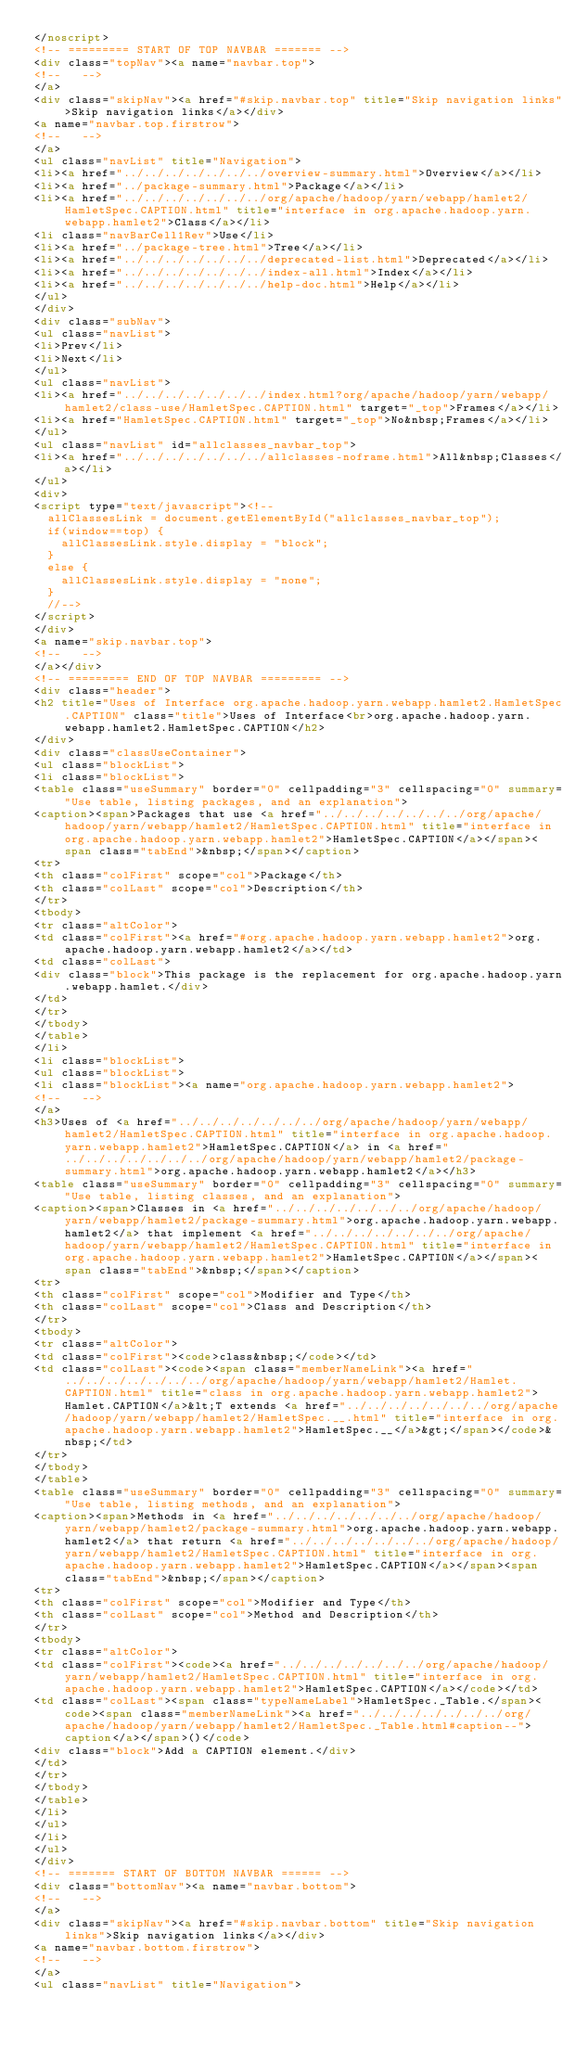<code> <loc_0><loc_0><loc_500><loc_500><_HTML_></noscript>
<!-- ========= START OF TOP NAVBAR ======= -->
<div class="topNav"><a name="navbar.top">
<!--   -->
</a>
<div class="skipNav"><a href="#skip.navbar.top" title="Skip navigation links">Skip navigation links</a></div>
<a name="navbar.top.firstrow">
<!--   -->
</a>
<ul class="navList" title="Navigation">
<li><a href="../../../../../../../overview-summary.html">Overview</a></li>
<li><a href="../package-summary.html">Package</a></li>
<li><a href="../../../../../../../org/apache/hadoop/yarn/webapp/hamlet2/HamletSpec.CAPTION.html" title="interface in org.apache.hadoop.yarn.webapp.hamlet2">Class</a></li>
<li class="navBarCell1Rev">Use</li>
<li><a href="../package-tree.html">Tree</a></li>
<li><a href="../../../../../../../deprecated-list.html">Deprecated</a></li>
<li><a href="../../../../../../../index-all.html">Index</a></li>
<li><a href="../../../../../../../help-doc.html">Help</a></li>
</ul>
</div>
<div class="subNav">
<ul class="navList">
<li>Prev</li>
<li>Next</li>
</ul>
<ul class="navList">
<li><a href="../../../../../../../index.html?org/apache/hadoop/yarn/webapp/hamlet2/class-use/HamletSpec.CAPTION.html" target="_top">Frames</a></li>
<li><a href="HamletSpec.CAPTION.html" target="_top">No&nbsp;Frames</a></li>
</ul>
<ul class="navList" id="allclasses_navbar_top">
<li><a href="../../../../../../../allclasses-noframe.html">All&nbsp;Classes</a></li>
</ul>
<div>
<script type="text/javascript"><!--
  allClassesLink = document.getElementById("allclasses_navbar_top");
  if(window==top) {
    allClassesLink.style.display = "block";
  }
  else {
    allClassesLink.style.display = "none";
  }
  //-->
</script>
</div>
<a name="skip.navbar.top">
<!--   -->
</a></div>
<!-- ========= END OF TOP NAVBAR ========= -->
<div class="header">
<h2 title="Uses of Interface org.apache.hadoop.yarn.webapp.hamlet2.HamletSpec.CAPTION" class="title">Uses of Interface<br>org.apache.hadoop.yarn.webapp.hamlet2.HamletSpec.CAPTION</h2>
</div>
<div class="classUseContainer">
<ul class="blockList">
<li class="blockList">
<table class="useSummary" border="0" cellpadding="3" cellspacing="0" summary="Use table, listing packages, and an explanation">
<caption><span>Packages that use <a href="../../../../../../../org/apache/hadoop/yarn/webapp/hamlet2/HamletSpec.CAPTION.html" title="interface in org.apache.hadoop.yarn.webapp.hamlet2">HamletSpec.CAPTION</a></span><span class="tabEnd">&nbsp;</span></caption>
<tr>
<th class="colFirst" scope="col">Package</th>
<th class="colLast" scope="col">Description</th>
</tr>
<tbody>
<tr class="altColor">
<td class="colFirst"><a href="#org.apache.hadoop.yarn.webapp.hamlet2">org.apache.hadoop.yarn.webapp.hamlet2</a></td>
<td class="colLast">
<div class="block">This package is the replacement for org.apache.hadoop.yarn.webapp.hamlet.</div>
</td>
</tr>
</tbody>
</table>
</li>
<li class="blockList">
<ul class="blockList">
<li class="blockList"><a name="org.apache.hadoop.yarn.webapp.hamlet2">
<!--   -->
</a>
<h3>Uses of <a href="../../../../../../../org/apache/hadoop/yarn/webapp/hamlet2/HamletSpec.CAPTION.html" title="interface in org.apache.hadoop.yarn.webapp.hamlet2">HamletSpec.CAPTION</a> in <a href="../../../../../../../org/apache/hadoop/yarn/webapp/hamlet2/package-summary.html">org.apache.hadoop.yarn.webapp.hamlet2</a></h3>
<table class="useSummary" border="0" cellpadding="3" cellspacing="0" summary="Use table, listing classes, and an explanation">
<caption><span>Classes in <a href="../../../../../../../org/apache/hadoop/yarn/webapp/hamlet2/package-summary.html">org.apache.hadoop.yarn.webapp.hamlet2</a> that implement <a href="../../../../../../../org/apache/hadoop/yarn/webapp/hamlet2/HamletSpec.CAPTION.html" title="interface in org.apache.hadoop.yarn.webapp.hamlet2">HamletSpec.CAPTION</a></span><span class="tabEnd">&nbsp;</span></caption>
<tr>
<th class="colFirst" scope="col">Modifier and Type</th>
<th class="colLast" scope="col">Class and Description</th>
</tr>
<tbody>
<tr class="altColor">
<td class="colFirst"><code>class&nbsp;</code></td>
<td class="colLast"><code><span class="memberNameLink"><a href="../../../../../../../org/apache/hadoop/yarn/webapp/hamlet2/Hamlet.CAPTION.html" title="class in org.apache.hadoop.yarn.webapp.hamlet2">Hamlet.CAPTION</a>&lt;T extends <a href="../../../../../../../org/apache/hadoop/yarn/webapp/hamlet2/HamletSpec.__.html" title="interface in org.apache.hadoop.yarn.webapp.hamlet2">HamletSpec.__</a>&gt;</span></code>&nbsp;</td>
</tr>
</tbody>
</table>
<table class="useSummary" border="0" cellpadding="3" cellspacing="0" summary="Use table, listing methods, and an explanation">
<caption><span>Methods in <a href="../../../../../../../org/apache/hadoop/yarn/webapp/hamlet2/package-summary.html">org.apache.hadoop.yarn.webapp.hamlet2</a> that return <a href="../../../../../../../org/apache/hadoop/yarn/webapp/hamlet2/HamletSpec.CAPTION.html" title="interface in org.apache.hadoop.yarn.webapp.hamlet2">HamletSpec.CAPTION</a></span><span class="tabEnd">&nbsp;</span></caption>
<tr>
<th class="colFirst" scope="col">Modifier and Type</th>
<th class="colLast" scope="col">Method and Description</th>
</tr>
<tbody>
<tr class="altColor">
<td class="colFirst"><code><a href="../../../../../../../org/apache/hadoop/yarn/webapp/hamlet2/HamletSpec.CAPTION.html" title="interface in org.apache.hadoop.yarn.webapp.hamlet2">HamletSpec.CAPTION</a></code></td>
<td class="colLast"><span class="typeNameLabel">HamletSpec._Table.</span><code><span class="memberNameLink"><a href="../../../../../../../org/apache/hadoop/yarn/webapp/hamlet2/HamletSpec._Table.html#caption--">caption</a></span>()</code>
<div class="block">Add a CAPTION element.</div>
</td>
</tr>
</tbody>
</table>
</li>
</ul>
</li>
</ul>
</div>
<!-- ======= START OF BOTTOM NAVBAR ====== -->
<div class="bottomNav"><a name="navbar.bottom">
<!--   -->
</a>
<div class="skipNav"><a href="#skip.navbar.bottom" title="Skip navigation links">Skip navigation links</a></div>
<a name="navbar.bottom.firstrow">
<!--   -->
</a>
<ul class="navList" title="Navigation"></code> 